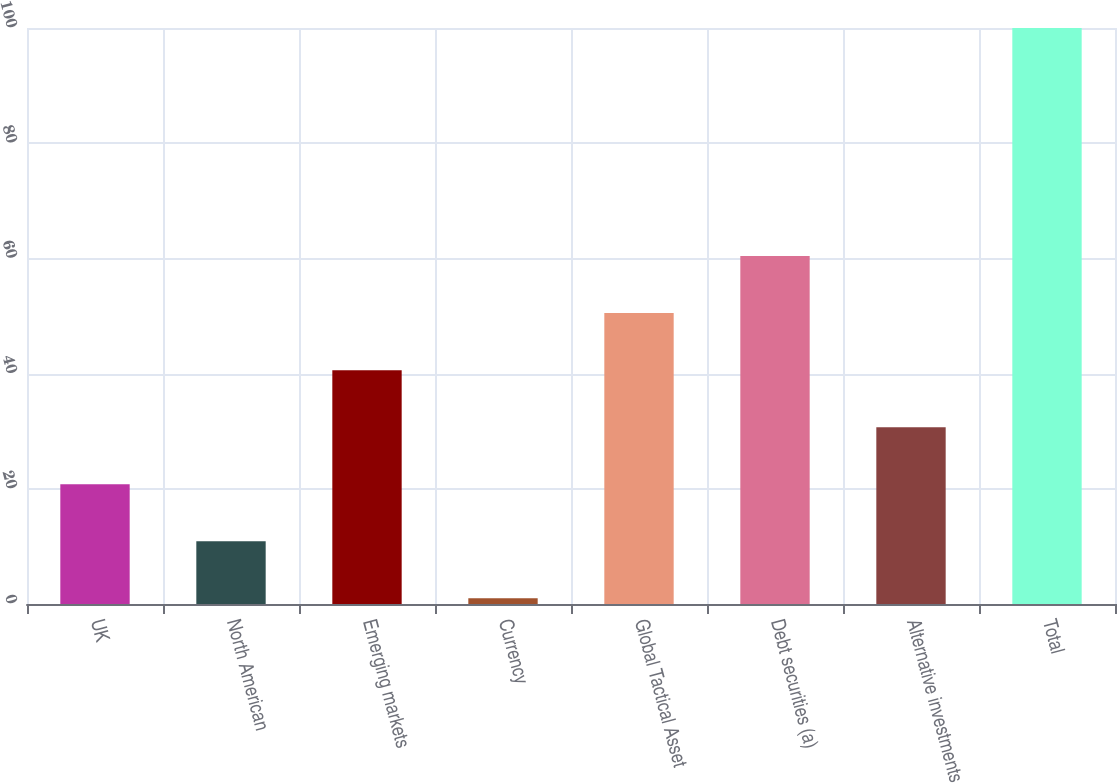Convert chart. <chart><loc_0><loc_0><loc_500><loc_500><bar_chart><fcel>UK<fcel>North American<fcel>Emerging markets<fcel>Currency<fcel>Global Tactical Asset<fcel>Debt securities (a)<fcel>Alternative investments<fcel>Total<nl><fcel>20.8<fcel>10.9<fcel>40.6<fcel>1<fcel>50.5<fcel>60.4<fcel>30.7<fcel>100<nl></chart> 